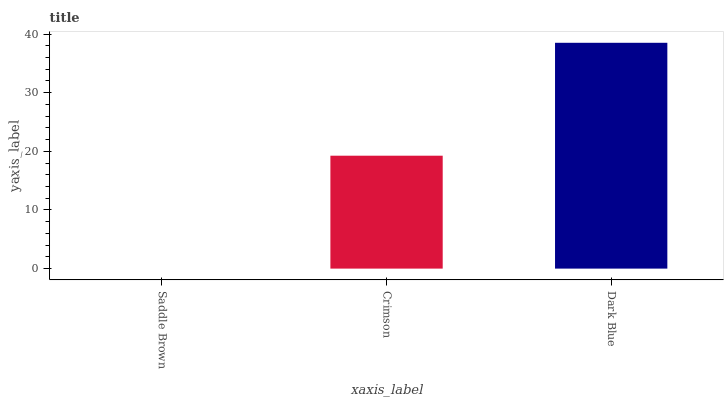Is Saddle Brown the minimum?
Answer yes or no. Yes. Is Dark Blue the maximum?
Answer yes or no. Yes. Is Crimson the minimum?
Answer yes or no. No. Is Crimson the maximum?
Answer yes or no. No. Is Crimson greater than Saddle Brown?
Answer yes or no. Yes. Is Saddle Brown less than Crimson?
Answer yes or no. Yes. Is Saddle Brown greater than Crimson?
Answer yes or no. No. Is Crimson less than Saddle Brown?
Answer yes or no. No. Is Crimson the high median?
Answer yes or no. Yes. Is Crimson the low median?
Answer yes or no. Yes. Is Dark Blue the high median?
Answer yes or no. No. Is Dark Blue the low median?
Answer yes or no. No. 